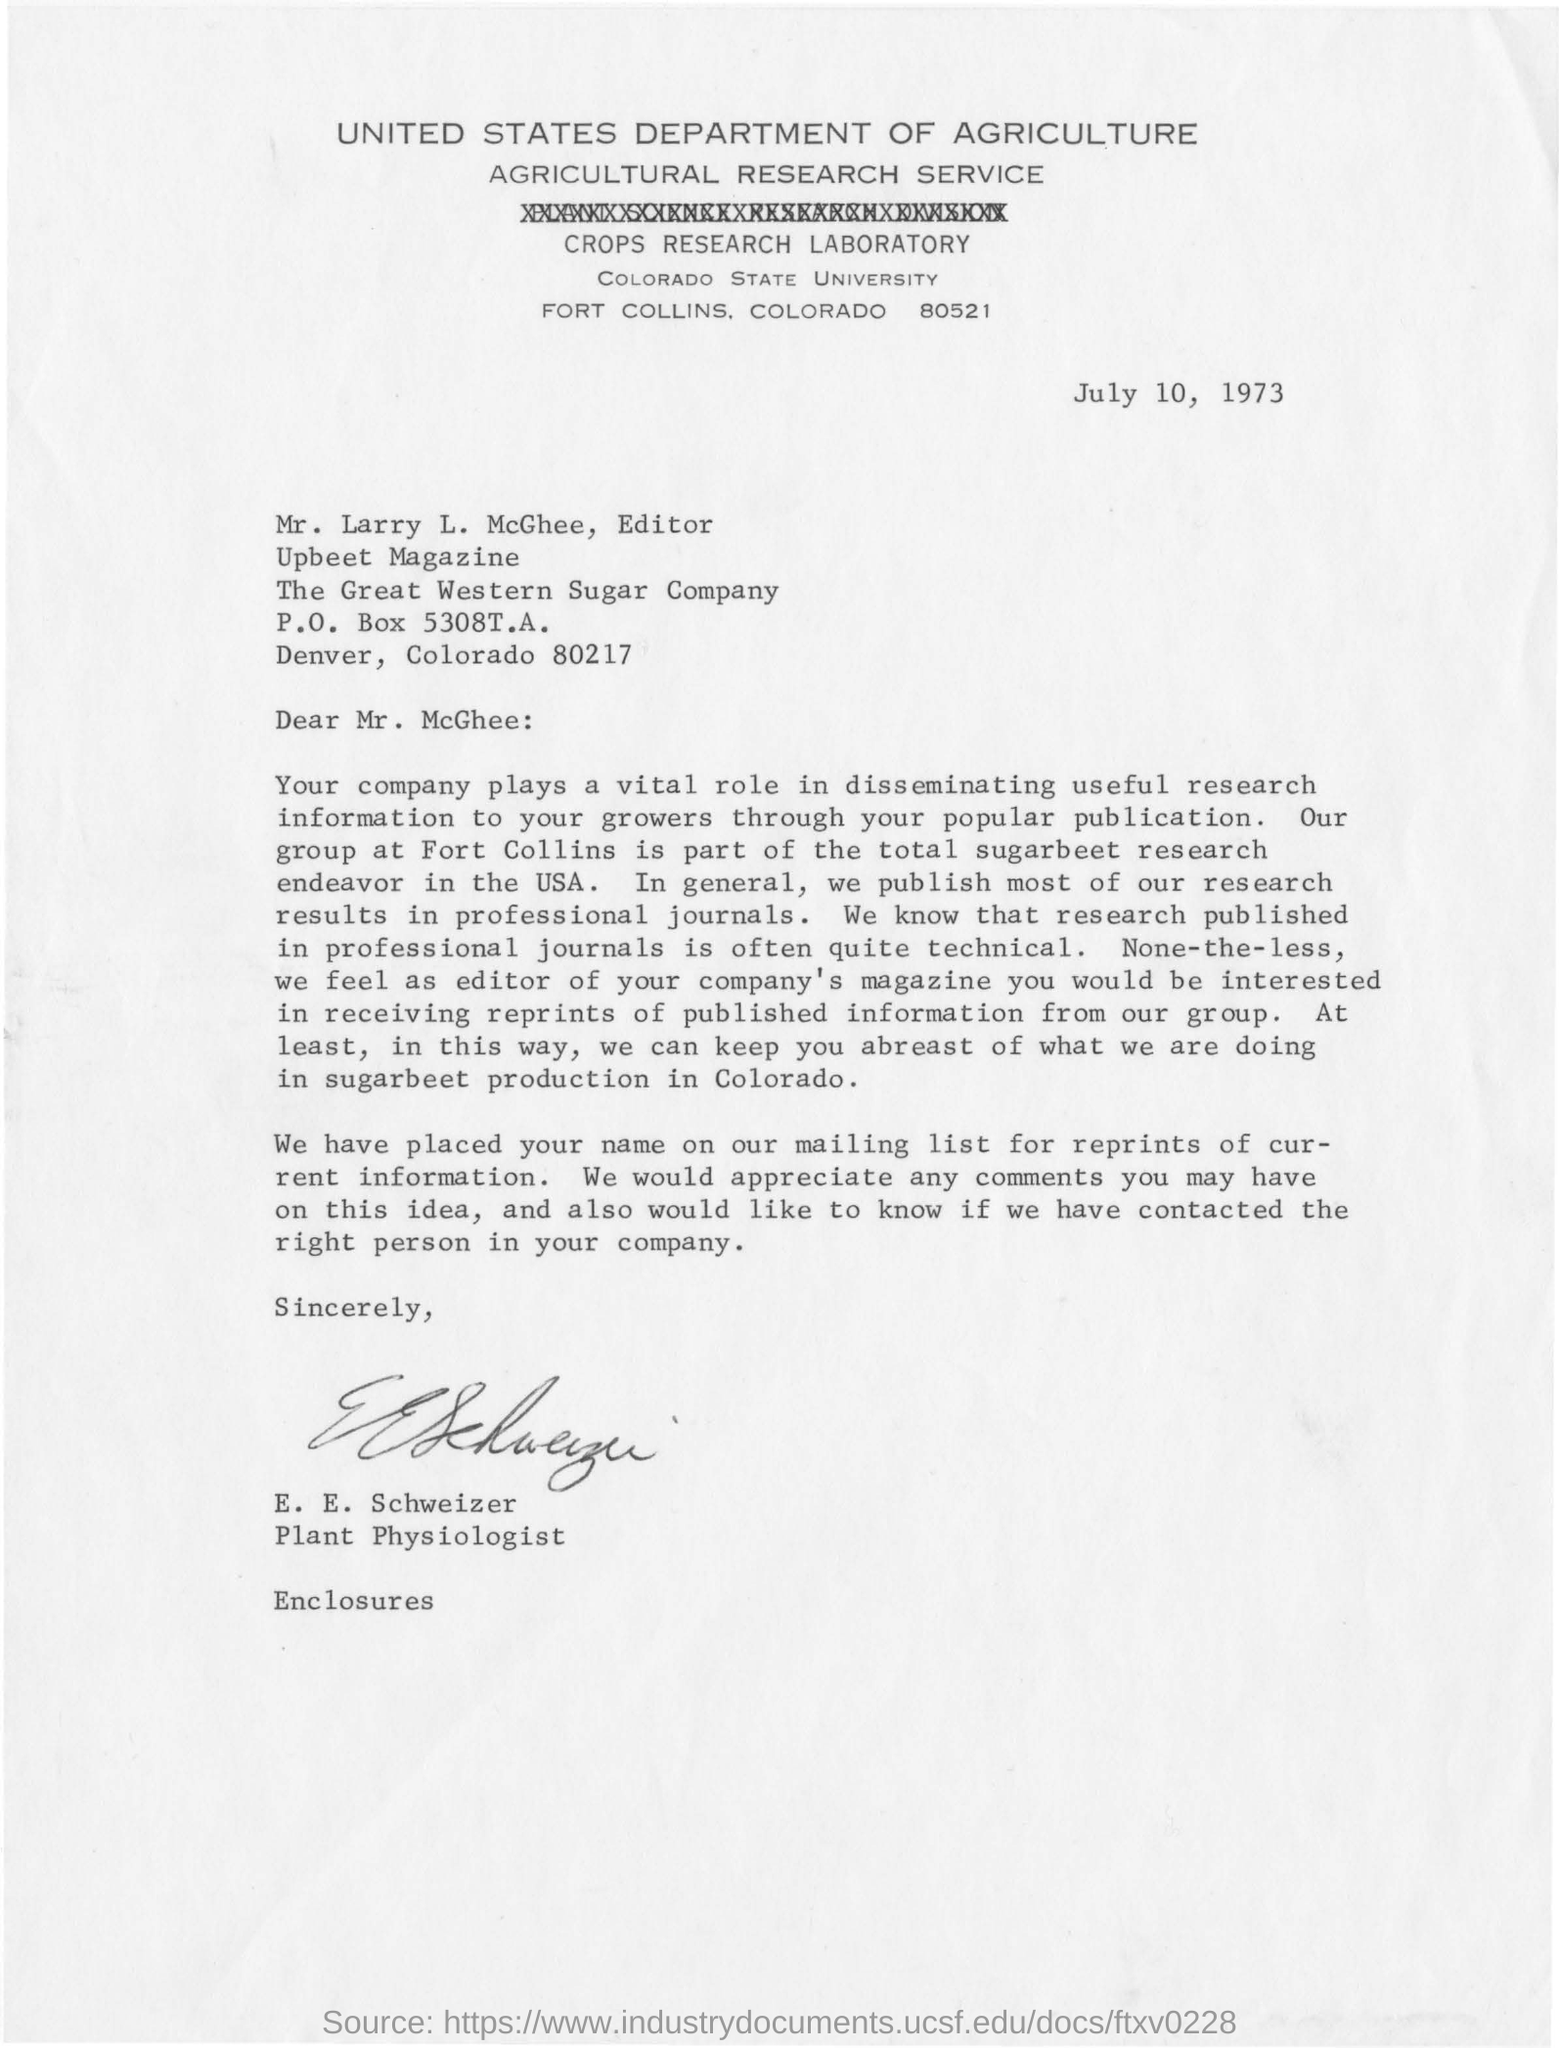Outline some significant characteristics in this image. E.E. Schweizer is a plant physiologist. The Great Western Sugar Company is located in Denver, Colorado, specifically at 80217. The letter is from the United States Department of Agriculture. The P.O. Box number is 5308T.A. The editor of the Upbeet magazine is Mr. Larry L. McGhee. 